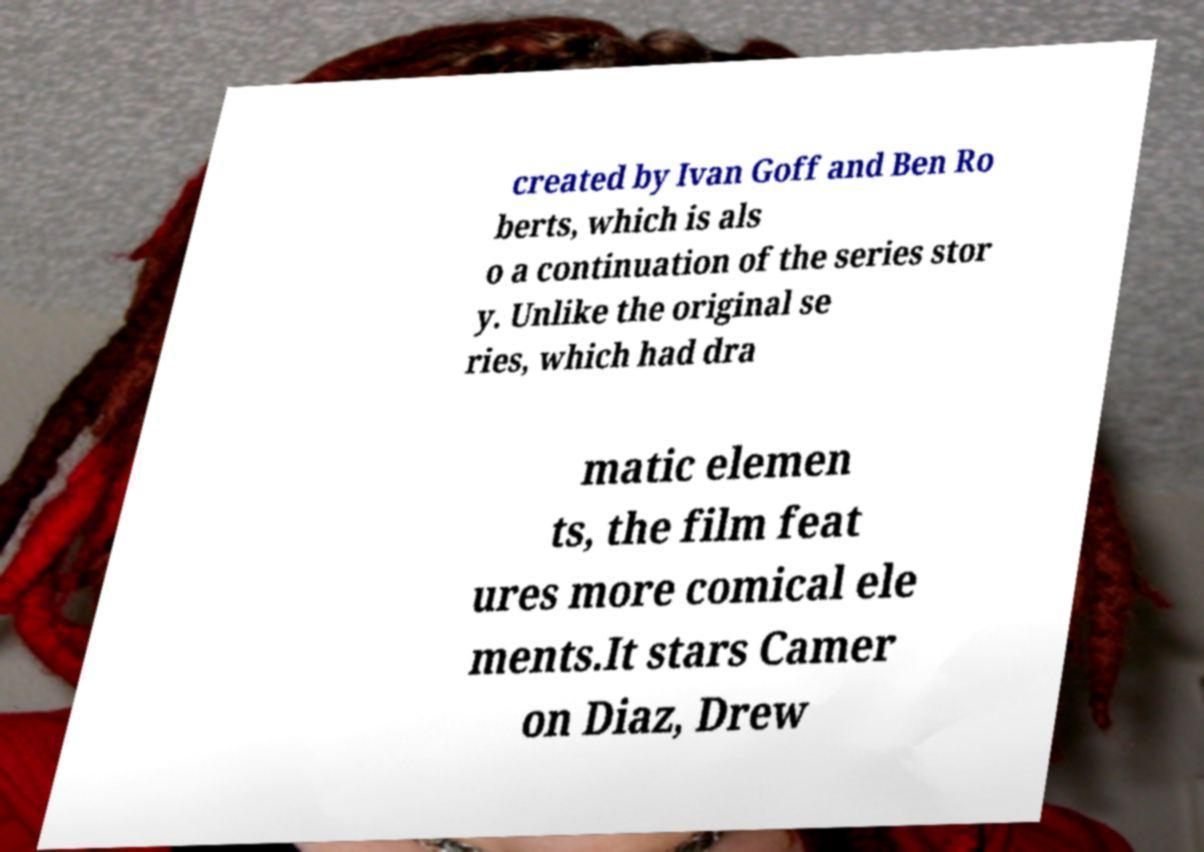Can you accurately transcribe the text from the provided image for me? created by Ivan Goff and Ben Ro berts, which is als o a continuation of the series stor y. Unlike the original se ries, which had dra matic elemen ts, the film feat ures more comical ele ments.It stars Camer on Diaz, Drew 